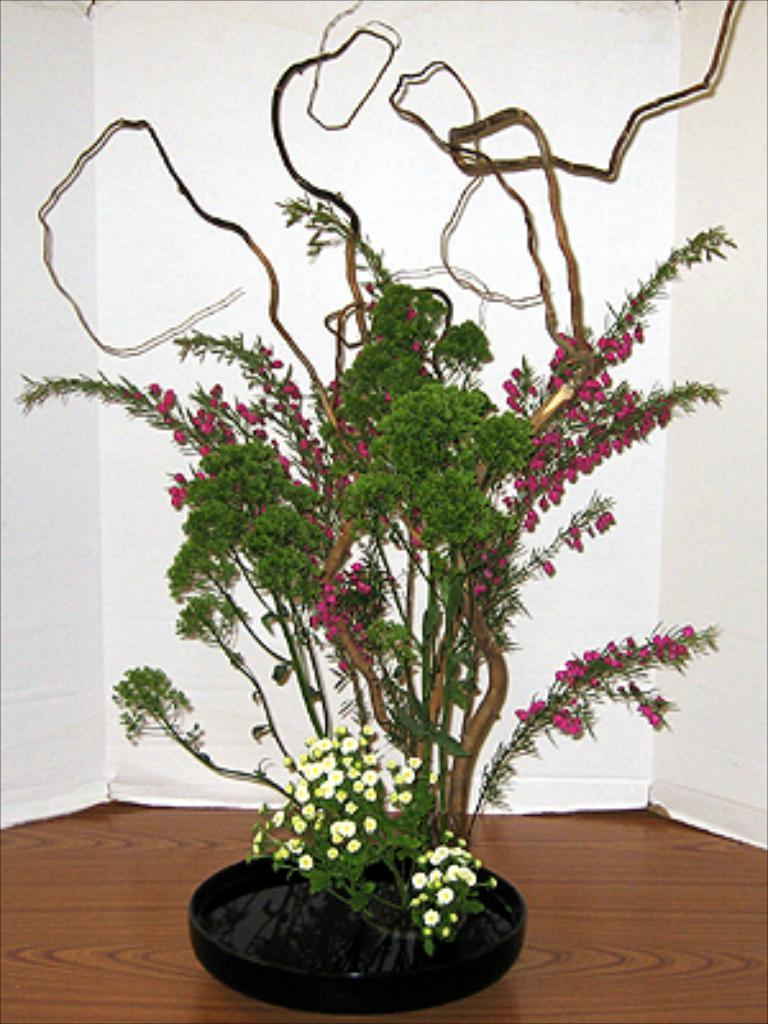What type of plant is in the image? There is a plant in the image, but the specific type is not mentioned. What can be seen growing on the plant? There are flowers in the image. What is visible at the bottom of the image? The floor is visible at the bottom of the image. What material can be seen in the background of the image? There is plywood visible in the background of the image. What type of grain can be seen growing in the image? There is no grain present in the image; it features a plant with flowers. What scent can be detected from the flowers in the image? The image is not accompanied by any scent, so it is not possible to determine the scent of the flowers. 